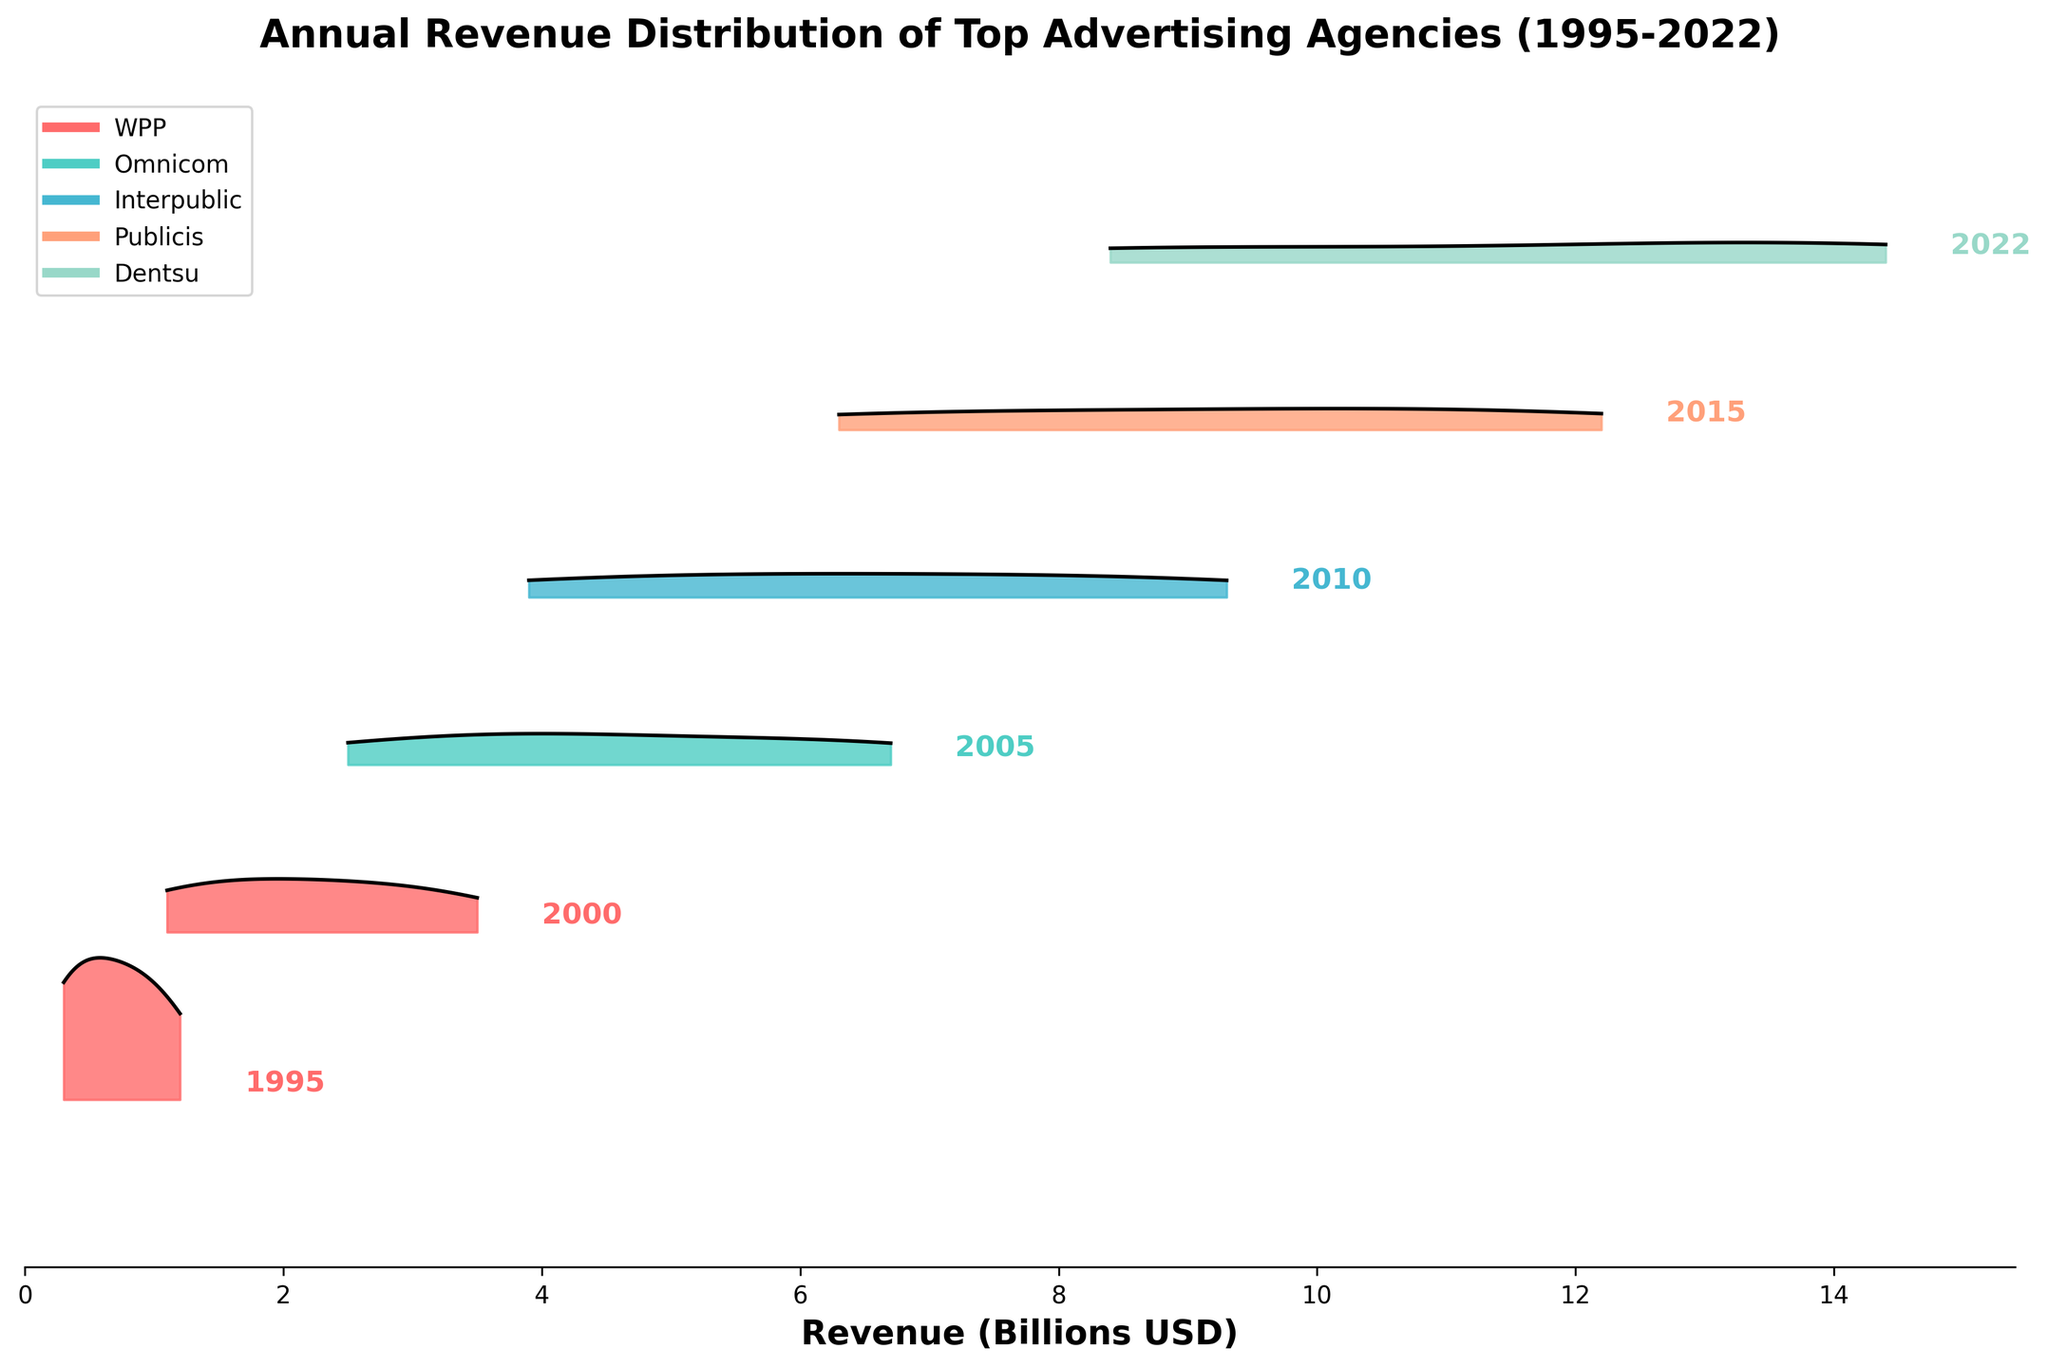what is the title of the figure? The title of the figure is placed at the top and reads "Annual Revenue Distribution of Top Advertising Agencies (1995-2022)"
Answer: Annual Revenue Distribution of Top Advertising Agencies (1995-2022) Which color represents the year 2010? Each year is represented by a color from the custom colormap. For the year 2010, it would be the middle color in the gradient used, which is likely around a blue or cooler color based on standard sequential color schemes.
Answer: Blue What year had the highest peak in revenue distribution? By observing the ridgelines, the height of the peak indicates the highest revenue density. The year 2022 appears to have the tallest peak near the right side of the plot.
Answer: 2022 Compare the revenue distributions between 2000 and 2010. Which year shows a wider spread? A wider spread indicates more variation in revenues among the top agencies. 2010 shows a broader distribution compared to the year 2000, which has a more concentrated curve.
Answer: 2010 Between which years did the revenue of the highest agency shift the most significantly? Observing the horizontal range of revenues, the largest shift seems to occur between 2000 and 2005, as the range stretches far more to the right.
Answer: 2000 to 2005 What is the range of revenue for the top advertising agencies in the year 2022? The range can be identified by looking at the furthest extents of the ridgeline for 2022. It spans from near 8 to around 14.4 billion USD.
Answer: 8 to 14.4 billion USD How did Dentsu's revenue change from 1995 to 2022? By following the changes over the years within the ridgeline, Dentsu starts at 0.3 billion USD in 1995 and increases to 8.4 billion USD in 2022.
Answer: Increased Which agency shows the second-largest revenue in the year 2022? By looking at the peak positions for each agency in 2022, Omnicom, with a peak at 13.7 billion USD, shows the second-largest revenue after WPP.
Answer: Omnicom Did any agency have a decrease in revenue in any period? Scanning through the years, no agency shows a decrease; all have increasing trends.
Answer: No 